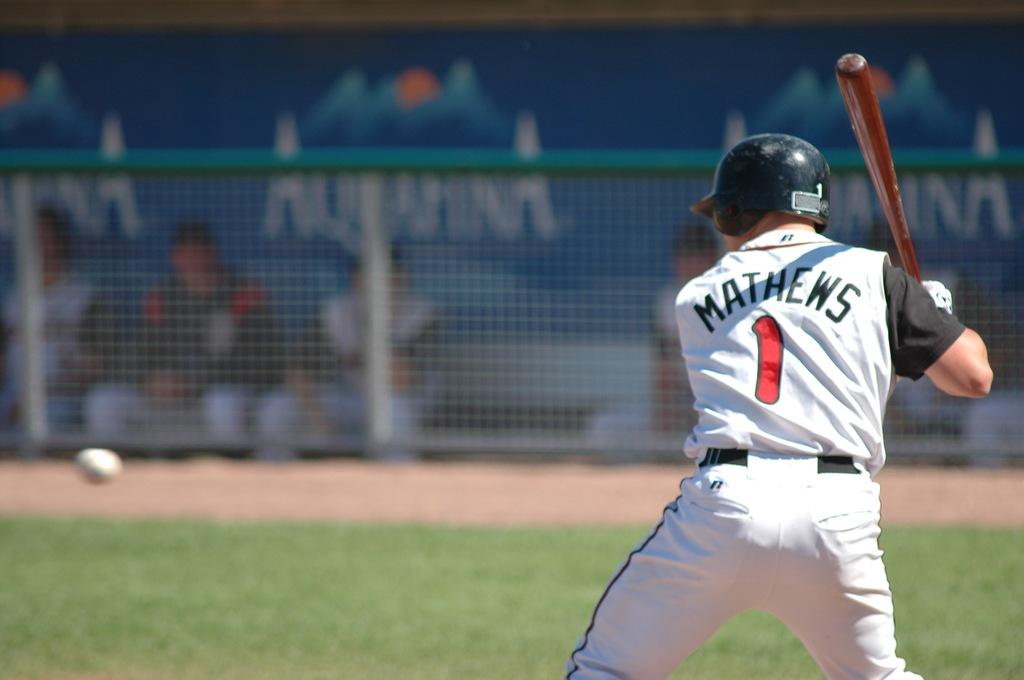What company is in the background?
Make the answer very short. Aquafina. 